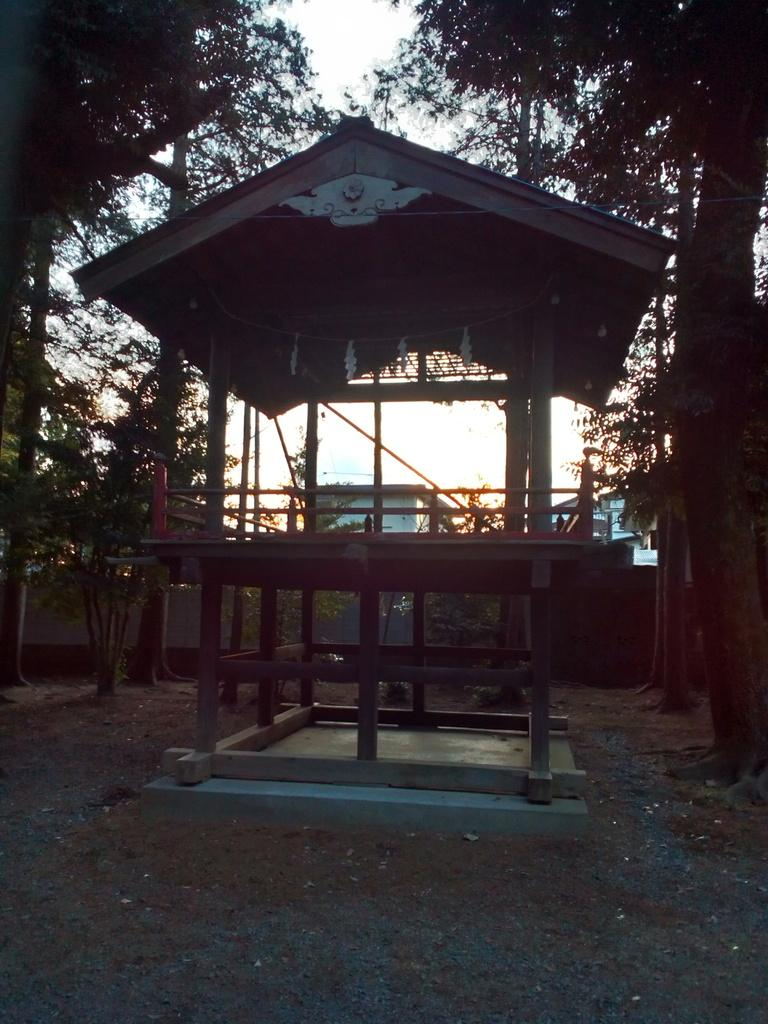What structure is located in the foreground of the image? There is a shed in the foreground of the image. What can be seen at the bottom of the image? The ground is visible at the bottom of the image. What type of vegetation is in the background of the image? There are trees in the background of the image. What is visible in the background of the image besides the trees? The sky is visible in the background of the image. What type of jeans is the tree wearing in the image? Trees do not wear jeans, as they are not human or capable of wearing clothing. 